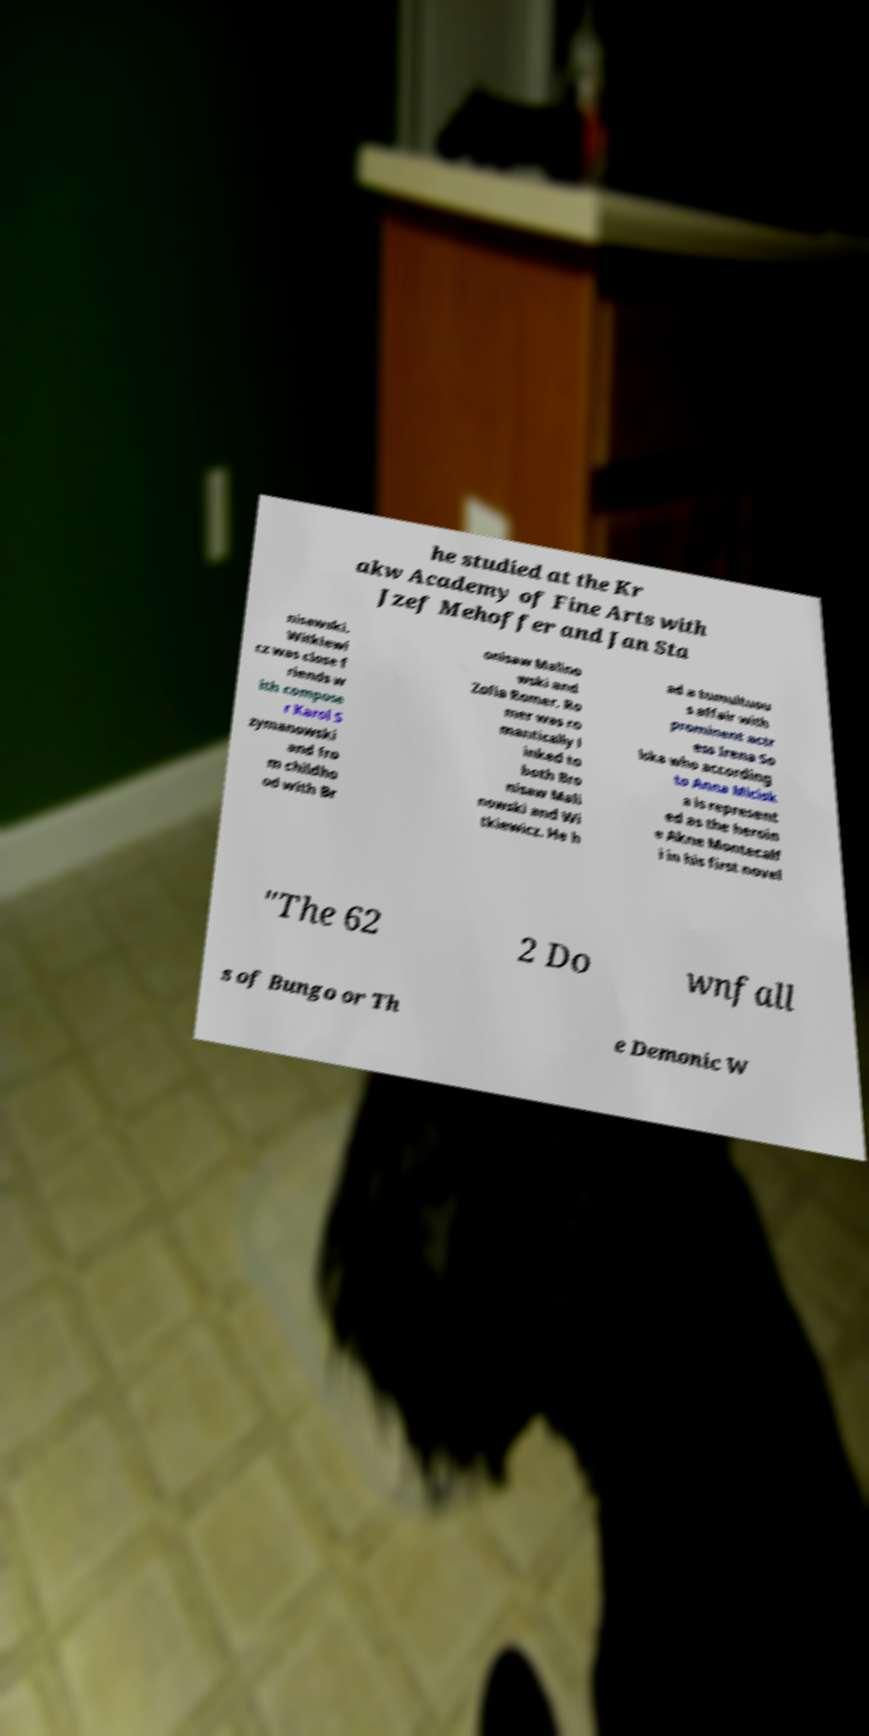Please read and relay the text visible in this image. What does it say? he studied at the Kr akw Academy of Fine Arts with Jzef Mehoffer and Jan Sta nisawski. Witkiewi cz was close f riends w ith compose r Karol S zymanowski and fro m childho od with Br onisaw Malino wski and Zofia Romer. Ro mer was ro mantically l inked to both Bro nisaw Mali nowski and Wi tkiewicz. He h ad a tumultuou s affair with prominent actr ess Irena So lska who according to Anna Micisk a is represent ed as the heroin e Akne Montecalf i in his first novel "The 62 2 Do wnfall s of Bungo or Th e Demonic W 